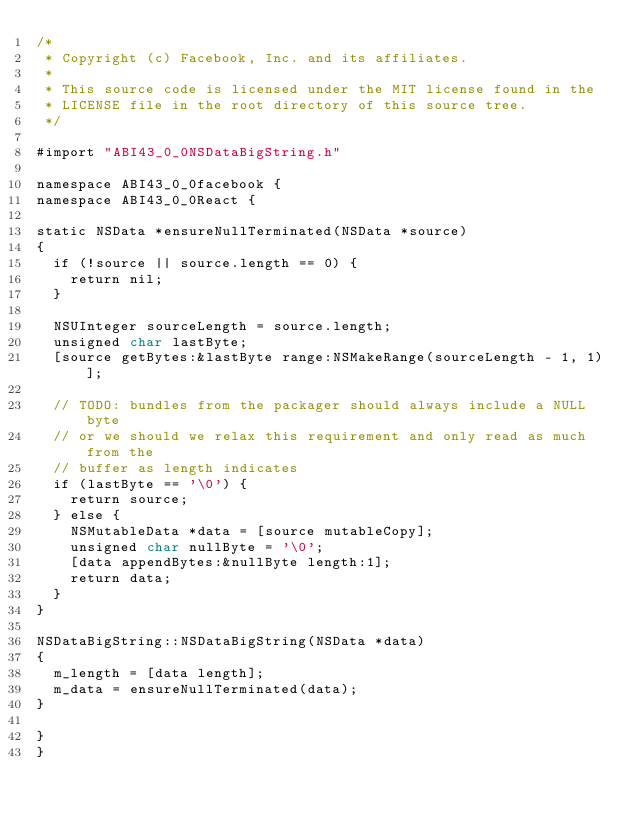Convert code to text. <code><loc_0><loc_0><loc_500><loc_500><_ObjectiveC_>/*
 * Copyright (c) Facebook, Inc. and its affiliates.
 *
 * This source code is licensed under the MIT license found in the
 * LICENSE file in the root directory of this source tree.
 */

#import "ABI43_0_0NSDataBigString.h"

namespace ABI43_0_0facebook {
namespace ABI43_0_0React {

static NSData *ensureNullTerminated(NSData *source)
{
  if (!source || source.length == 0) {
    return nil;
  }

  NSUInteger sourceLength = source.length;
  unsigned char lastByte;
  [source getBytes:&lastByte range:NSMakeRange(sourceLength - 1, 1)];

  // TODO: bundles from the packager should always include a NULL byte
  // or we should we relax this requirement and only read as much from the
  // buffer as length indicates
  if (lastByte == '\0') {
    return source;
  } else {
    NSMutableData *data = [source mutableCopy];
    unsigned char nullByte = '\0';
    [data appendBytes:&nullByte length:1];
    return data;
  }
}

NSDataBigString::NSDataBigString(NSData *data)
{
  m_length = [data length];
  m_data = ensureNullTerminated(data);
}

}
}
</code> 